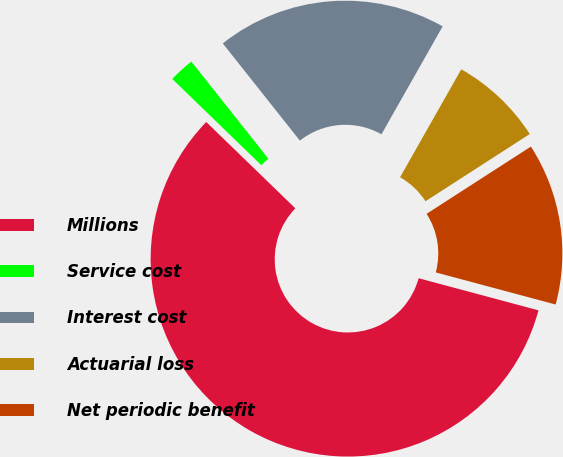Convert chart. <chart><loc_0><loc_0><loc_500><loc_500><pie_chart><fcel>Millions<fcel>Service cost<fcel>Interest cost<fcel>Actuarial loss<fcel>Net periodic benefit<nl><fcel>58.09%<fcel>2.08%<fcel>18.88%<fcel>7.68%<fcel>13.28%<nl></chart> 